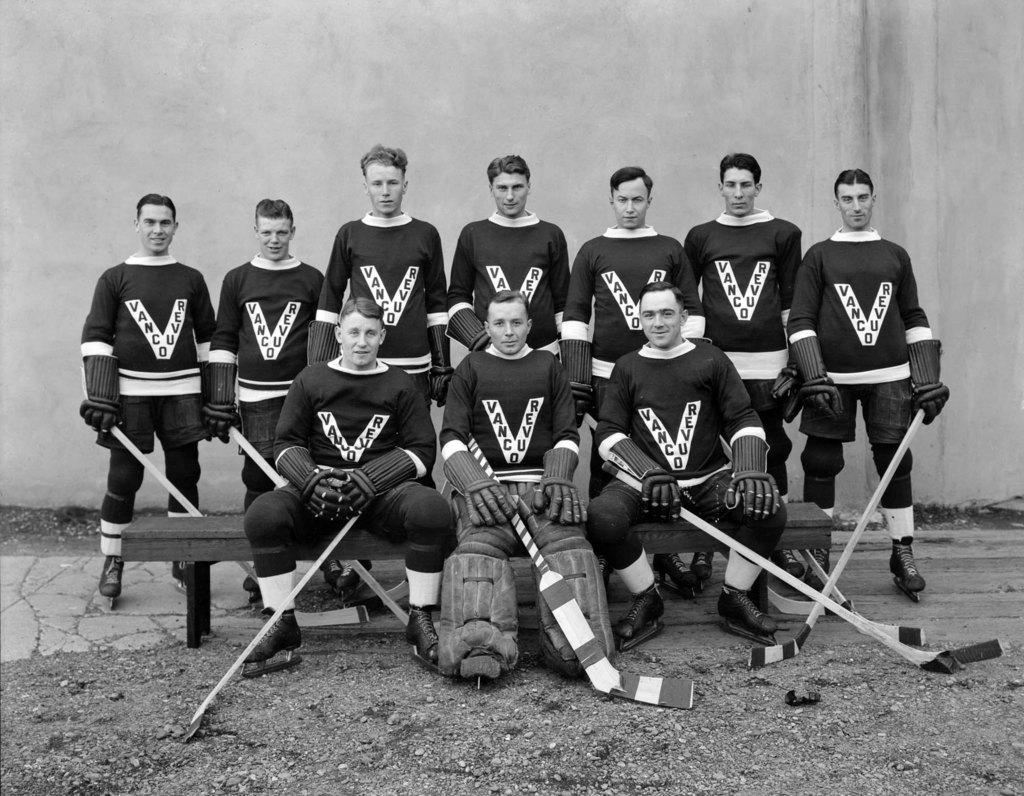<image>
Summarize the visual content of the image. Ten players for the ice hockey team Vancouver in black and white photo shoot. 